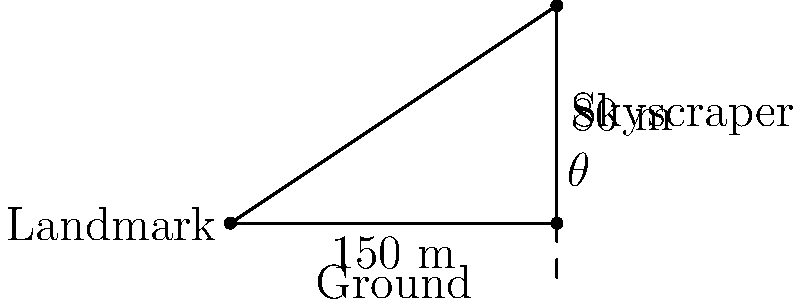From the top of a skyscraper in downtown Montreal, you observe a nearby landmark. The skyscraper is 80 meters tall, and the horizontal distance to the landmark is 150 meters. Calculate the angle of elevation ($\theta$) from the top of the skyscraper to the landmark. To solve this problem, we'll use trigonometry:

1) First, identify the triangle: We have a right-angled triangle where:
   - The adjacent side is the horizontal distance (150 m)
   - The opposite side is the height of the skyscraper (80 m)
   - The angle we're looking for ($\theta$) is at the top of the skyscraper

2) We need to use the tangent function, as we have the opposite and adjacent sides:

   $\tan(\theta) = \frac{\text{opposite}}{\text{adjacent}} = \frac{80}{150}$

3) To find $\theta$, we need to use the inverse tangent (arctan or $\tan^{-1}$):

   $\theta = \tan^{-1}(\frac{80}{150})$

4) Calculate:
   $\theta = \tan^{-1}(0.5333...)$
   $\theta \approx 28.07$ degrees

5) Round to two decimal places:
   $\theta \approx 28.07°$
Answer: $28.07°$ 